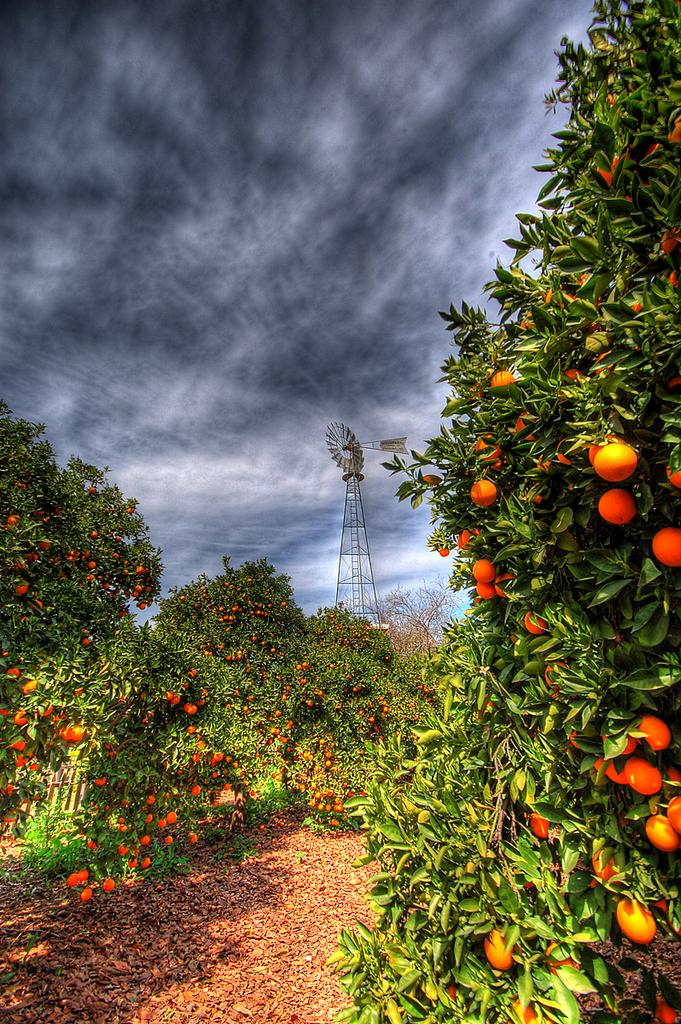What type of plants can be seen in the image? There are plants with fruits in the image. What can be seen in the background of the image? There is a metal structure and the sky visible in the background of the image. What type of line can be seen connecting the plants in the image? There is no line connecting the plants in the image. Is there a zoo present in the image? There is no zoo present in the image. 